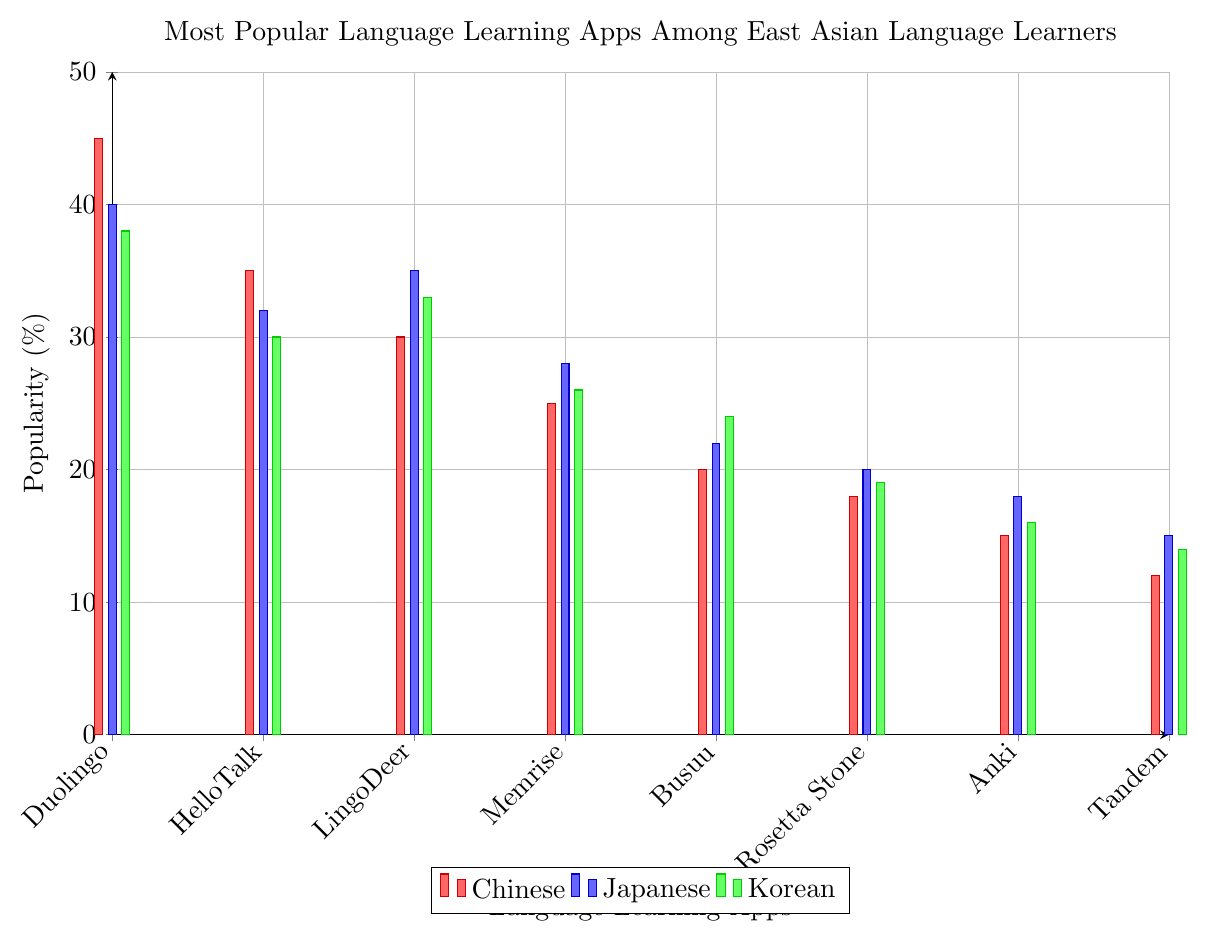Which app is the least popular among Chinese language learners? Looking at the red bars representing Chinese language learners, the shortest bar indicates the least popular app. Tandem has the lowest value of 12%.
Answer: Tandem Which app is the most popular amongst Japanese language learners? For Japanese language learners, the tallest blue bar represents Duolingo with a value of 40%.
Answer: Duolingo Which app has the highest popularity percentage across all three languages? Among all the apps in the plot, Duolingo has the highest popularity percentage (45%) for Chinese language learners.
Answer: Duolingo By how much is the popularity of Duolingo higher for Chinese learners compared to Korean learners? The popularity of Duolingo for Chinese learners is 45%, and for Korean learners is 38%. The difference is 45% - 38% = 7%.
Answer: 7% Which two apps have the same popularity percentage among Korean learners? In the green bars for Korean learners, Anki and Tandem both have the same percentage, which is 16%.
Answer: Anki and Tandem What is the average popularity percentage of Memrise for the three languages? Add the percentages for Memrise for Chinese (25%), Japanese (28%), and Korean (26%) and divide by 3. The average is (25% + 28% + 26%) / 3 = 26.33%.
Answer: 26.33% Which language has the highest average popularity across all apps? First, sum the percentages for each language and then divide by the number of apps (8). Chinese: (45+35+30+25+20+18+15+12) = 200, Japanese: (40+32+35+28+22+20+18+15) = 210, Korean: (38+30+33+26+24+19+16+14) = 200. The average for Japanese learners is highest, which is 210 / 8 = 26.25%.
Answer: Japanese Which app shows the least variation in popularity across all three languages? Calculate the range (max - min) for the popularity of each app. Tandem has the smallest range: for Chinese (12%), Japanese (15%), and Korean (14%), the range is 15% - 12% = 3%.
Answer: Tandem How much more popular is HelloTalk for Chinese learners compared to Korean learners? HelloTalk is 35% popular among Chinese learners and 30% popular among Korean learners. The difference is 35% - 30% = 5%.
Answer: 5% Which app is consistently more popular for Chinese learners compared to Japanese learners? By comparing the red and blue bars, Duolingo (45% vs. 40%) and HelloTalk (35% vs. 32%) are more popular among Chinese learners compared to Japanese learners.
Answer: Duolingo and HelloTalk 